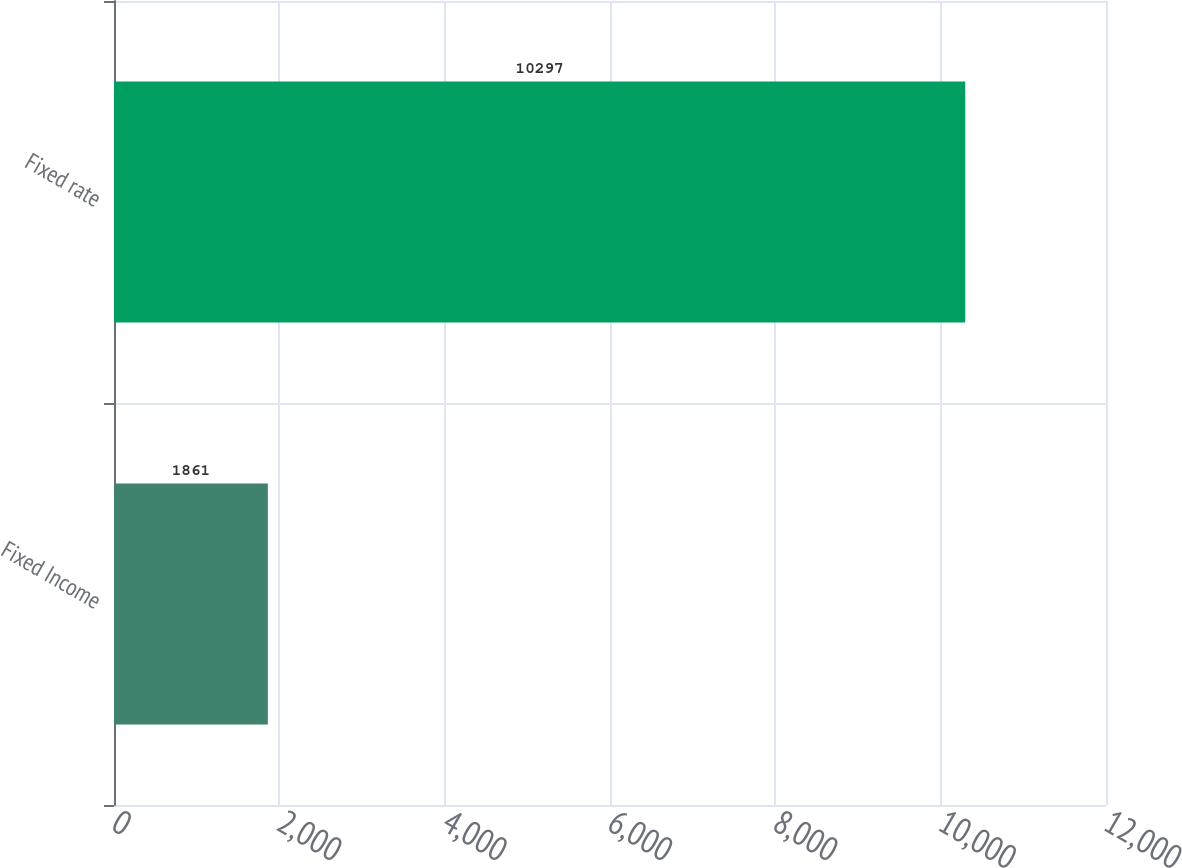Convert chart. <chart><loc_0><loc_0><loc_500><loc_500><bar_chart><fcel>Fixed Income<fcel>Fixed rate<nl><fcel>1861<fcel>10297<nl></chart> 